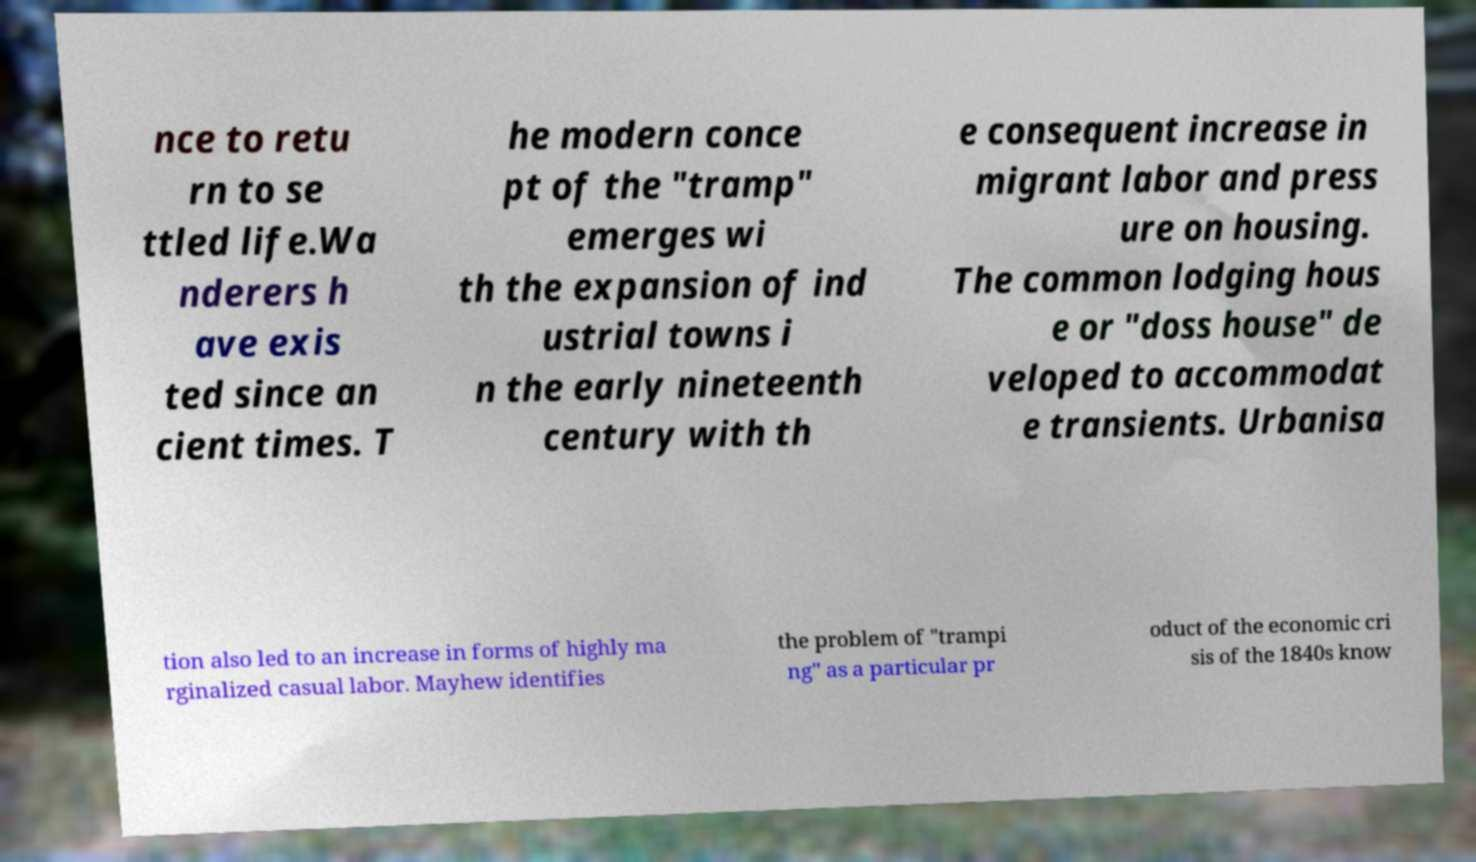For documentation purposes, I need the text within this image transcribed. Could you provide that? nce to retu rn to se ttled life.Wa nderers h ave exis ted since an cient times. T he modern conce pt of the "tramp" emerges wi th the expansion of ind ustrial towns i n the early nineteenth century with th e consequent increase in migrant labor and press ure on housing. The common lodging hous e or "doss house" de veloped to accommodat e transients. Urbanisa tion also led to an increase in forms of highly ma rginalized casual labor. Mayhew identifies the problem of "trampi ng" as a particular pr oduct of the economic cri sis of the 1840s know 